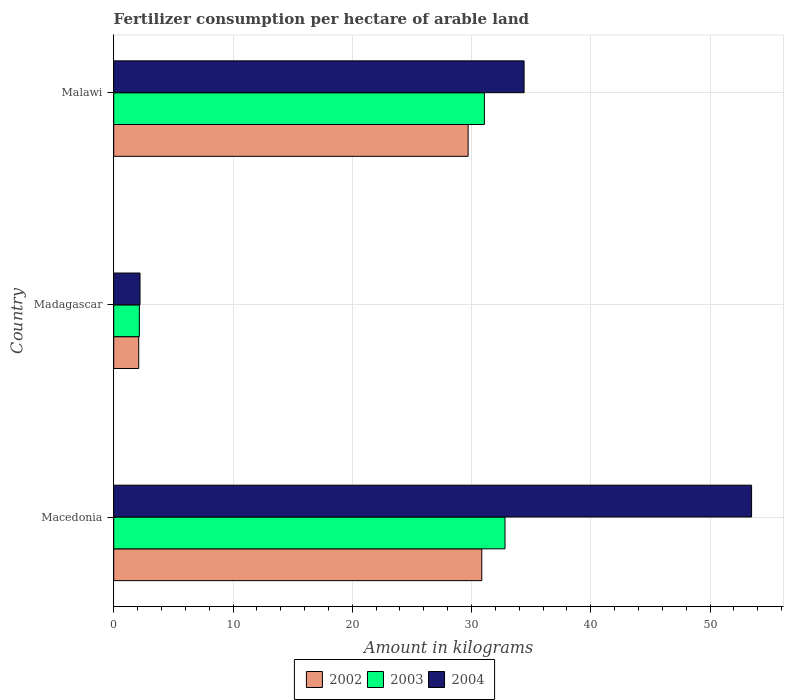How many bars are there on the 1st tick from the top?
Make the answer very short. 3. What is the label of the 1st group of bars from the top?
Provide a succinct answer. Malawi. What is the amount of fertilizer consumption in 2004 in Macedonia?
Ensure brevity in your answer.  53.48. Across all countries, what is the maximum amount of fertilizer consumption in 2002?
Your answer should be compact. 30.86. Across all countries, what is the minimum amount of fertilizer consumption in 2002?
Provide a succinct answer. 2.09. In which country was the amount of fertilizer consumption in 2004 maximum?
Your answer should be very brief. Macedonia. In which country was the amount of fertilizer consumption in 2002 minimum?
Offer a very short reply. Madagascar. What is the total amount of fertilizer consumption in 2004 in the graph?
Offer a terse response. 90.09. What is the difference between the amount of fertilizer consumption in 2002 in Macedonia and that in Madagascar?
Provide a succinct answer. 28.77. What is the difference between the amount of fertilizer consumption in 2002 in Macedonia and the amount of fertilizer consumption in 2003 in Madagascar?
Give a very brief answer. 28.71. What is the average amount of fertilizer consumption in 2003 per country?
Your answer should be compact. 22.01. What is the difference between the amount of fertilizer consumption in 2004 and amount of fertilizer consumption in 2003 in Malawi?
Your answer should be very brief. 3.33. In how many countries, is the amount of fertilizer consumption in 2004 greater than 52 kg?
Keep it short and to the point. 1. What is the ratio of the amount of fertilizer consumption in 2004 in Macedonia to that in Malawi?
Ensure brevity in your answer.  1.55. Is the amount of fertilizer consumption in 2002 in Madagascar less than that in Malawi?
Your response must be concise. Yes. Is the difference between the amount of fertilizer consumption in 2004 in Macedonia and Madagascar greater than the difference between the amount of fertilizer consumption in 2003 in Macedonia and Madagascar?
Ensure brevity in your answer.  Yes. What is the difference between the highest and the second highest amount of fertilizer consumption in 2002?
Keep it short and to the point. 1.15. What is the difference between the highest and the lowest amount of fertilizer consumption in 2003?
Offer a very short reply. 30.66. In how many countries, is the amount of fertilizer consumption in 2004 greater than the average amount of fertilizer consumption in 2004 taken over all countries?
Offer a very short reply. 2. Is the sum of the amount of fertilizer consumption in 2003 in Madagascar and Malawi greater than the maximum amount of fertilizer consumption in 2004 across all countries?
Offer a terse response. No. What does the 3rd bar from the top in Malawi represents?
Your response must be concise. 2002. What does the 2nd bar from the bottom in Madagascar represents?
Offer a very short reply. 2003. Are all the bars in the graph horizontal?
Your answer should be compact. Yes. How many countries are there in the graph?
Offer a very short reply. 3. What is the difference between two consecutive major ticks on the X-axis?
Provide a short and direct response. 10. Are the values on the major ticks of X-axis written in scientific E-notation?
Your answer should be compact. No. Does the graph contain any zero values?
Make the answer very short. No. Where does the legend appear in the graph?
Provide a succinct answer. Bottom center. What is the title of the graph?
Give a very brief answer. Fertilizer consumption per hectare of arable land. Does "1981" appear as one of the legend labels in the graph?
Offer a terse response. No. What is the label or title of the X-axis?
Provide a succinct answer. Amount in kilograms. What is the label or title of the Y-axis?
Provide a short and direct response. Country. What is the Amount in kilograms in 2002 in Macedonia?
Make the answer very short. 30.86. What is the Amount in kilograms in 2003 in Macedonia?
Your response must be concise. 32.8. What is the Amount in kilograms in 2004 in Macedonia?
Make the answer very short. 53.48. What is the Amount in kilograms of 2002 in Madagascar?
Give a very brief answer. 2.09. What is the Amount in kilograms in 2003 in Madagascar?
Offer a very short reply. 2.15. What is the Amount in kilograms of 2004 in Madagascar?
Provide a succinct answer. 2.2. What is the Amount in kilograms in 2002 in Malawi?
Offer a very short reply. 29.71. What is the Amount in kilograms in 2003 in Malawi?
Your response must be concise. 31.08. What is the Amount in kilograms in 2004 in Malawi?
Offer a very short reply. 34.41. Across all countries, what is the maximum Amount in kilograms in 2002?
Make the answer very short. 30.86. Across all countries, what is the maximum Amount in kilograms of 2003?
Give a very brief answer. 32.8. Across all countries, what is the maximum Amount in kilograms in 2004?
Make the answer very short. 53.48. Across all countries, what is the minimum Amount in kilograms of 2002?
Provide a short and direct response. 2.09. Across all countries, what is the minimum Amount in kilograms of 2003?
Provide a succinct answer. 2.15. Across all countries, what is the minimum Amount in kilograms of 2004?
Make the answer very short. 2.2. What is the total Amount in kilograms in 2002 in the graph?
Your answer should be compact. 62.67. What is the total Amount in kilograms in 2003 in the graph?
Give a very brief answer. 66.03. What is the total Amount in kilograms of 2004 in the graph?
Provide a short and direct response. 90.09. What is the difference between the Amount in kilograms in 2002 in Macedonia and that in Madagascar?
Offer a terse response. 28.77. What is the difference between the Amount in kilograms in 2003 in Macedonia and that in Madagascar?
Offer a terse response. 30.66. What is the difference between the Amount in kilograms in 2004 in Macedonia and that in Madagascar?
Offer a terse response. 51.28. What is the difference between the Amount in kilograms in 2002 in Macedonia and that in Malawi?
Ensure brevity in your answer.  1.15. What is the difference between the Amount in kilograms in 2003 in Macedonia and that in Malawi?
Keep it short and to the point. 1.73. What is the difference between the Amount in kilograms in 2004 in Macedonia and that in Malawi?
Your response must be concise. 19.08. What is the difference between the Amount in kilograms of 2002 in Madagascar and that in Malawi?
Offer a very short reply. -27.62. What is the difference between the Amount in kilograms of 2003 in Madagascar and that in Malawi?
Give a very brief answer. -28.93. What is the difference between the Amount in kilograms of 2004 in Madagascar and that in Malawi?
Your answer should be very brief. -32.2. What is the difference between the Amount in kilograms of 2002 in Macedonia and the Amount in kilograms of 2003 in Madagascar?
Provide a short and direct response. 28.71. What is the difference between the Amount in kilograms of 2002 in Macedonia and the Amount in kilograms of 2004 in Madagascar?
Give a very brief answer. 28.66. What is the difference between the Amount in kilograms of 2003 in Macedonia and the Amount in kilograms of 2004 in Madagascar?
Offer a very short reply. 30.6. What is the difference between the Amount in kilograms of 2002 in Macedonia and the Amount in kilograms of 2003 in Malawi?
Your answer should be very brief. -0.22. What is the difference between the Amount in kilograms in 2002 in Macedonia and the Amount in kilograms in 2004 in Malawi?
Offer a very short reply. -3.55. What is the difference between the Amount in kilograms in 2003 in Macedonia and the Amount in kilograms in 2004 in Malawi?
Your response must be concise. -1.6. What is the difference between the Amount in kilograms in 2002 in Madagascar and the Amount in kilograms in 2003 in Malawi?
Keep it short and to the point. -28.98. What is the difference between the Amount in kilograms of 2002 in Madagascar and the Amount in kilograms of 2004 in Malawi?
Your answer should be compact. -32.31. What is the difference between the Amount in kilograms in 2003 in Madagascar and the Amount in kilograms in 2004 in Malawi?
Keep it short and to the point. -32.26. What is the average Amount in kilograms of 2002 per country?
Provide a succinct answer. 20.89. What is the average Amount in kilograms in 2003 per country?
Ensure brevity in your answer.  22.01. What is the average Amount in kilograms in 2004 per country?
Offer a very short reply. 30.03. What is the difference between the Amount in kilograms in 2002 and Amount in kilograms in 2003 in Macedonia?
Offer a terse response. -1.95. What is the difference between the Amount in kilograms of 2002 and Amount in kilograms of 2004 in Macedonia?
Provide a short and direct response. -22.62. What is the difference between the Amount in kilograms of 2003 and Amount in kilograms of 2004 in Macedonia?
Provide a short and direct response. -20.68. What is the difference between the Amount in kilograms in 2002 and Amount in kilograms in 2003 in Madagascar?
Ensure brevity in your answer.  -0.05. What is the difference between the Amount in kilograms of 2002 and Amount in kilograms of 2004 in Madagascar?
Make the answer very short. -0.11. What is the difference between the Amount in kilograms in 2003 and Amount in kilograms in 2004 in Madagascar?
Keep it short and to the point. -0.05. What is the difference between the Amount in kilograms in 2002 and Amount in kilograms in 2003 in Malawi?
Ensure brevity in your answer.  -1.36. What is the difference between the Amount in kilograms of 2002 and Amount in kilograms of 2004 in Malawi?
Make the answer very short. -4.69. What is the difference between the Amount in kilograms of 2003 and Amount in kilograms of 2004 in Malawi?
Ensure brevity in your answer.  -3.33. What is the ratio of the Amount in kilograms in 2002 in Macedonia to that in Madagascar?
Provide a succinct answer. 14.74. What is the ratio of the Amount in kilograms of 2003 in Macedonia to that in Madagascar?
Offer a terse response. 15.27. What is the ratio of the Amount in kilograms in 2004 in Macedonia to that in Madagascar?
Your response must be concise. 24.28. What is the ratio of the Amount in kilograms of 2002 in Macedonia to that in Malawi?
Provide a succinct answer. 1.04. What is the ratio of the Amount in kilograms in 2003 in Macedonia to that in Malawi?
Provide a short and direct response. 1.06. What is the ratio of the Amount in kilograms of 2004 in Macedonia to that in Malawi?
Your response must be concise. 1.55. What is the ratio of the Amount in kilograms in 2002 in Madagascar to that in Malawi?
Ensure brevity in your answer.  0.07. What is the ratio of the Amount in kilograms in 2003 in Madagascar to that in Malawi?
Provide a succinct answer. 0.07. What is the ratio of the Amount in kilograms in 2004 in Madagascar to that in Malawi?
Offer a terse response. 0.06. What is the difference between the highest and the second highest Amount in kilograms of 2002?
Keep it short and to the point. 1.15. What is the difference between the highest and the second highest Amount in kilograms of 2003?
Your response must be concise. 1.73. What is the difference between the highest and the second highest Amount in kilograms of 2004?
Ensure brevity in your answer.  19.08. What is the difference between the highest and the lowest Amount in kilograms in 2002?
Ensure brevity in your answer.  28.77. What is the difference between the highest and the lowest Amount in kilograms in 2003?
Make the answer very short. 30.66. What is the difference between the highest and the lowest Amount in kilograms in 2004?
Your response must be concise. 51.28. 